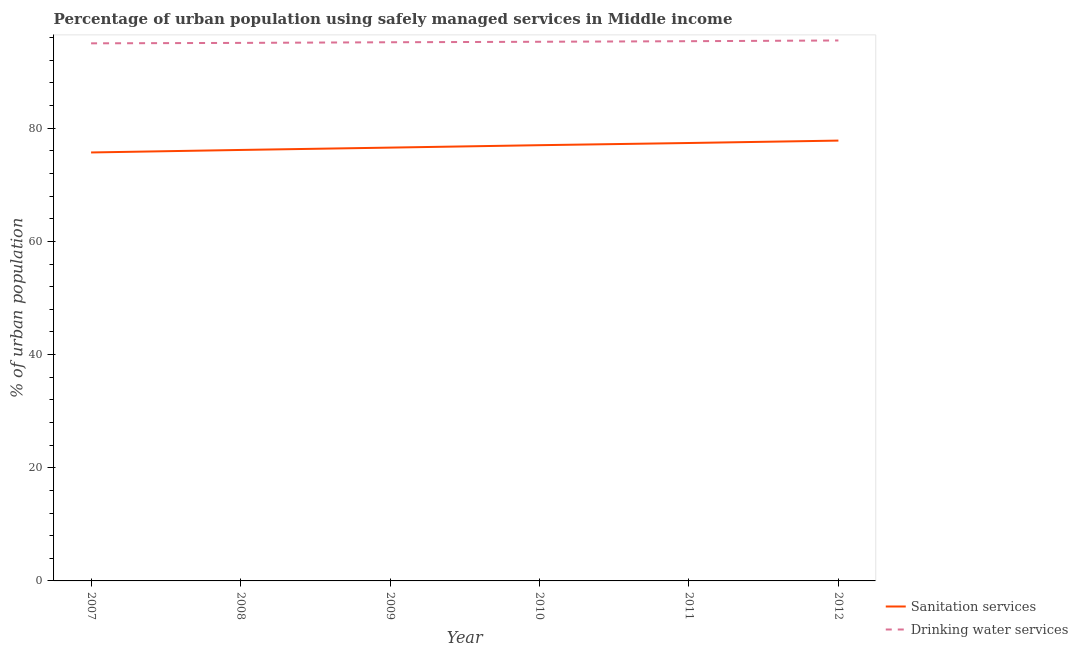Does the line corresponding to percentage of urban population who used sanitation services intersect with the line corresponding to percentage of urban population who used drinking water services?
Provide a short and direct response. No. Is the number of lines equal to the number of legend labels?
Give a very brief answer. Yes. What is the percentage of urban population who used sanitation services in 2012?
Provide a succinct answer. 77.81. Across all years, what is the maximum percentage of urban population who used drinking water services?
Your answer should be compact. 95.5. Across all years, what is the minimum percentage of urban population who used drinking water services?
Give a very brief answer. 94.99. In which year was the percentage of urban population who used drinking water services maximum?
Your response must be concise. 2012. What is the total percentage of urban population who used drinking water services in the graph?
Ensure brevity in your answer.  571.39. What is the difference between the percentage of urban population who used sanitation services in 2011 and that in 2012?
Keep it short and to the point. -0.42. What is the difference between the percentage of urban population who used drinking water services in 2007 and the percentage of urban population who used sanitation services in 2011?
Provide a short and direct response. 17.61. What is the average percentage of urban population who used sanitation services per year?
Your answer should be very brief. 76.77. In the year 2008, what is the difference between the percentage of urban population who used sanitation services and percentage of urban population who used drinking water services?
Your answer should be compact. -18.92. What is the ratio of the percentage of urban population who used sanitation services in 2007 to that in 2011?
Your answer should be very brief. 0.98. What is the difference between the highest and the second highest percentage of urban population who used drinking water services?
Your answer should be compact. 0.13. What is the difference between the highest and the lowest percentage of urban population who used drinking water services?
Ensure brevity in your answer.  0.51. In how many years, is the percentage of urban population who used sanitation services greater than the average percentage of urban population who used sanitation services taken over all years?
Offer a very short reply. 3. Is the sum of the percentage of urban population who used drinking water services in 2007 and 2008 greater than the maximum percentage of urban population who used sanitation services across all years?
Your answer should be very brief. Yes. What is the difference between two consecutive major ticks on the Y-axis?
Provide a short and direct response. 20. Where does the legend appear in the graph?
Provide a short and direct response. Bottom right. How are the legend labels stacked?
Provide a succinct answer. Vertical. What is the title of the graph?
Your answer should be compact. Percentage of urban population using safely managed services in Middle income. Does "State government" appear as one of the legend labels in the graph?
Give a very brief answer. No. What is the label or title of the Y-axis?
Ensure brevity in your answer.  % of urban population. What is the % of urban population of Sanitation services in 2007?
Keep it short and to the point. 75.71. What is the % of urban population of Drinking water services in 2007?
Ensure brevity in your answer.  94.99. What is the % of urban population of Sanitation services in 2008?
Offer a very short reply. 76.15. What is the % of urban population in Drinking water services in 2008?
Offer a terse response. 95.07. What is the % of urban population of Sanitation services in 2009?
Offer a terse response. 76.57. What is the % of urban population in Drinking water services in 2009?
Make the answer very short. 95.18. What is the % of urban population of Sanitation services in 2010?
Provide a succinct answer. 76.99. What is the % of urban population in Drinking water services in 2010?
Offer a very short reply. 95.27. What is the % of urban population of Sanitation services in 2011?
Provide a succinct answer. 77.38. What is the % of urban population of Drinking water services in 2011?
Make the answer very short. 95.37. What is the % of urban population in Sanitation services in 2012?
Your response must be concise. 77.81. What is the % of urban population of Drinking water services in 2012?
Keep it short and to the point. 95.5. Across all years, what is the maximum % of urban population in Sanitation services?
Give a very brief answer. 77.81. Across all years, what is the maximum % of urban population of Drinking water services?
Provide a succinct answer. 95.5. Across all years, what is the minimum % of urban population of Sanitation services?
Your response must be concise. 75.71. Across all years, what is the minimum % of urban population of Drinking water services?
Offer a terse response. 94.99. What is the total % of urban population of Sanitation services in the graph?
Your answer should be very brief. 460.62. What is the total % of urban population of Drinking water services in the graph?
Make the answer very short. 571.39. What is the difference between the % of urban population in Sanitation services in 2007 and that in 2008?
Provide a short and direct response. -0.44. What is the difference between the % of urban population of Drinking water services in 2007 and that in 2008?
Give a very brief answer. -0.08. What is the difference between the % of urban population in Sanitation services in 2007 and that in 2009?
Offer a terse response. -0.86. What is the difference between the % of urban population in Drinking water services in 2007 and that in 2009?
Provide a succinct answer. -0.19. What is the difference between the % of urban population in Sanitation services in 2007 and that in 2010?
Give a very brief answer. -1.28. What is the difference between the % of urban population in Drinking water services in 2007 and that in 2010?
Your response must be concise. -0.28. What is the difference between the % of urban population in Sanitation services in 2007 and that in 2011?
Provide a succinct answer. -1.67. What is the difference between the % of urban population in Drinking water services in 2007 and that in 2011?
Keep it short and to the point. -0.38. What is the difference between the % of urban population of Sanitation services in 2007 and that in 2012?
Your answer should be very brief. -2.1. What is the difference between the % of urban population of Drinking water services in 2007 and that in 2012?
Your response must be concise. -0.51. What is the difference between the % of urban population in Sanitation services in 2008 and that in 2009?
Ensure brevity in your answer.  -0.41. What is the difference between the % of urban population in Drinking water services in 2008 and that in 2009?
Provide a short and direct response. -0.11. What is the difference between the % of urban population of Sanitation services in 2008 and that in 2010?
Your answer should be very brief. -0.84. What is the difference between the % of urban population in Drinking water services in 2008 and that in 2010?
Your answer should be very brief. -0.2. What is the difference between the % of urban population of Sanitation services in 2008 and that in 2011?
Ensure brevity in your answer.  -1.23. What is the difference between the % of urban population in Drinking water services in 2008 and that in 2011?
Provide a succinct answer. -0.3. What is the difference between the % of urban population of Sanitation services in 2008 and that in 2012?
Offer a terse response. -1.65. What is the difference between the % of urban population of Drinking water services in 2008 and that in 2012?
Provide a succinct answer. -0.43. What is the difference between the % of urban population in Sanitation services in 2009 and that in 2010?
Your answer should be very brief. -0.43. What is the difference between the % of urban population of Drinking water services in 2009 and that in 2010?
Offer a terse response. -0.09. What is the difference between the % of urban population in Sanitation services in 2009 and that in 2011?
Your answer should be very brief. -0.82. What is the difference between the % of urban population in Drinking water services in 2009 and that in 2011?
Ensure brevity in your answer.  -0.19. What is the difference between the % of urban population of Sanitation services in 2009 and that in 2012?
Your answer should be very brief. -1.24. What is the difference between the % of urban population of Drinking water services in 2009 and that in 2012?
Your answer should be compact. -0.31. What is the difference between the % of urban population in Sanitation services in 2010 and that in 2011?
Your answer should be compact. -0.39. What is the difference between the % of urban population of Drinking water services in 2010 and that in 2011?
Provide a short and direct response. -0.1. What is the difference between the % of urban population in Sanitation services in 2010 and that in 2012?
Provide a succinct answer. -0.81. What is the difference between the % of urban population of Drinking water services in 2010 and that in 2012?
Provide a succinct answer. -0.23. What is the difference between the % of urban population in Sanitation services in 2011 and that in 2012?
Keep it short and to the point. -0.42. What is the difference between the % of urban population of Drinking water services in 2011 and that in 2012?
Your answer should be compact. -0.13. What is the difference between the % of urban population of Sanitation services in 2007 and the % of urban population of Drinking water services in 2008?
Ensure brevity in your answer.  -19.36. What is the difference between the % of urban population in Sanitation services in 2007 and the % of urban population in Drinking water services in 2009?
Your answer should be very brief. -19.47. What is the difference between the % of urban population of Sanitation services in 2007 and the % of urban population of Drinking water services in 2010?
Make the answer very short. -19.56. What is the difference between the % of urban population in Sanitation services in 2007 and the % of urban population in Drinking water services in 2011?
Your answer should be compact. -19.66. What is the difference between the % of urban population in Sanitation services in 2007 and the % of urban population in Drinking water services in 2012?
Your answer should be compact. -19.79. What is the difference between the % of urban population of Sanitation services in 2008 and the % of urban population of Drinking water services in 2009?
Provide a short and direct response. -19.03. What is the difference between the % of urban population in Sanitation services in 2008 and the % of urban population in Drinking water services in 2010?
Offer a terse response. -19.12. What is the difference between the % of urban population in Sanitation services in 2008 and the % of urban population in Drinking water services in 2011?
Provide a succinct answer. -19.22. What is the difference between the % of urban population in Sanitation services in 2008 and the % of urban population in Drinking water services in 2012?
Your response must be concise. -19.34. What is the difference between the % of urban population in Sanitation services in 2009 and the % of urban population in Drinking water services in 2010?
Your answer should be compact. -18.7. What is the difference between the % of urban population of Sanitation services in 2009 and the % of urban population of Drinking water services in 2011?
Ensure brevity in your answer.  -18.81. What is the difference between the % of urban population in Sanitation services in 2009 and the % of urban population in Drinking water services in 2012?
Give a very brief answer. -18.93. What is the difference between the % of urban population in Sanitation services in 2010 and the % of urban population in Drinking water services in 2011?
Provide a short and direct response. -18.38. What is the difference between the % of urban population in Sanitation services in 2010 and the % of urban population in Drinking water services in 2012?
Keep it short and to the point. -18.5. What is the difference between the % of urban population of Sanitation services in 2011 and the % of urban population of Drinking water services in 2012?
Ensure brevity in your answer.  -18.12. What is the average % of urban population of Sanitation services per year?
Ensure brevity in your answer.  76.77. What is the average % of urban population of Drinking water services per year?
Make the answer very short. 95.23. In the year 2007, what is the difference between the % of urban population of Sanitation services and % of urban population of Drinking water services?
Make the answer very short. -19.28. In the year 2008, what is the difference between the % of urban population of Sanitation services and % of urban population of Drinking water services?
Your answer should be very brief. -18.92. In the year 2009, what is the difference between the % of urban population in Sanitation services and % of urban population in Drinking water services?
Make the answer very short. -18.62. In the year 2010, what is the difference between the % of urban population in Sanitation services and % of urban population in Drinking water services?
Offer a terse response. -18.28. In the year 2011, what is the difference between the % of urban population in Sanitation services and % of urban population in Drinking water services?
Keep it short and to the point. -17.99. In the year 2012, what is the difference between the % of urban population of Sanitation services and % of urban population of Drinking water services?
Provide a short and direct response. -17.69. What is the ratio of the % of urban population in Sanitation services in 2007 to that in 2008?
Your answer should be very brief. 0.99. What is the ratio of the % of urban population of Drinking water services in 2007 to that in 2008?
Provide a short and direct response. 1. What is the ratio of the % of urban population of Sanitation services in 2007 to that in 2009?
Give a very brief answer. 0.99. What is the ratio of the % of urban population in Drinking water services in 2007 to that in 2009?
Offer a very short reply. 1. What is the ratio of the % of urban population of Sanitation services in 2007 to that in 2010?
Provide a short and direct response. 0.98. What is the ratio of the % of urban population in Sanitation services in 2007 to that in 2011?
Make the answer very short. 0.98. What is the ratio of the % of urban population in Sanitation services in 2007 to that in 2012?
Ensure brevity in your answer.  0.97. What is the ratio of the % of urban population of Drinking water services in 2007 to that in 2012?
Ensure brevity in your answer.  0.99. What is the ratio of the % of urban population in Sanitation services in 2008 to that in 2010?
Offer a very short reply. 0.99. What is the ratio of the % of urban population in Sanitation services in 2008 to that in 2011?
Your answer should be compact. 0.98. What is the ratio of the % of urban population of Drinking water services in 2008 to that in 2011?
Offer a terse response. 1. What is the ratio of the % of urban population in Sanitation services in 2008 to that in 2012?
Keep it short and to the point. 0.98. What is the ratio of the % of urban population of Sanitation services in 2009 to that in 2011?
Give a very brief answer. 0.99. What is the ratio of the % of urban population in Drinking water services in 2009 to that in 2011?
Offer a very short reply. 1. What is the ratio of the % of urban population of Sanitation services in 2009 to that in 2012?
Offer a very short reply. 0.98. What is the ratio of the % of urban population of Drinking water services in 2009 to that in 2012?
Make the answer very short. 1. What is the ratio of the % of urban population in Sanitation services in 2010 to that in 2011?
Offer a terse response. 0.99. What is the ratio of the % of urban population in Drinking water services in 2010 to that in 2011?
Your answer should be very brief. 1. What is the ratio of the % of urban population of Sanitation services in 2010 to that in 2012?
Provide a short and direct response. 0.99. What is the ratio of the % of urban population of Sanitation services in 2011 to that in 2012?
Provide a short and direct response. 0.99. What is the ratio of the % of urban population in Drinking water services in 2011 to that in 2012?
Keep it short and to the point. 1. What is the difference between the highest and the second highest % of urban population of Sanitation services?
Keep it short and to the point. 0.42. What is the difference between the highest and the second highest % of urban population in Drinking water services?
Provide a succinct answer. 0.13. What is the difference between the highest and the lowest % of urban population of Sanitation services?
Give a very brief answer. 2.1. What is the difference between the highest and the lowest % of urban population in Drinking water services?
Make the answer very short. 0.51. 